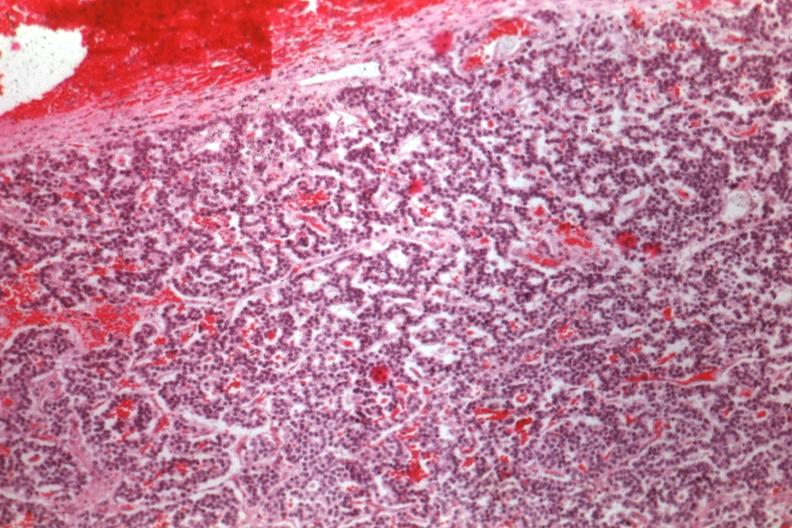s chromophobe adenoma present?
Answer the question using a single word or phrase. Yes 